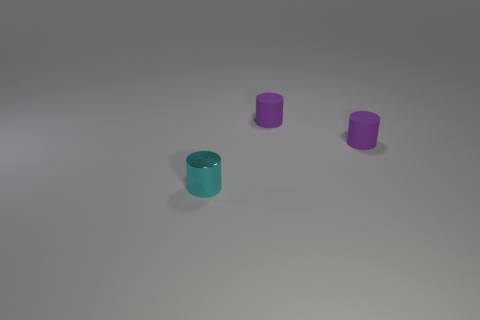What is the color of the shiny object? The color of the shiny object in the foreground appears to be a reflective cyan, characterized by its bluish-green hue that shines under the light source above. 